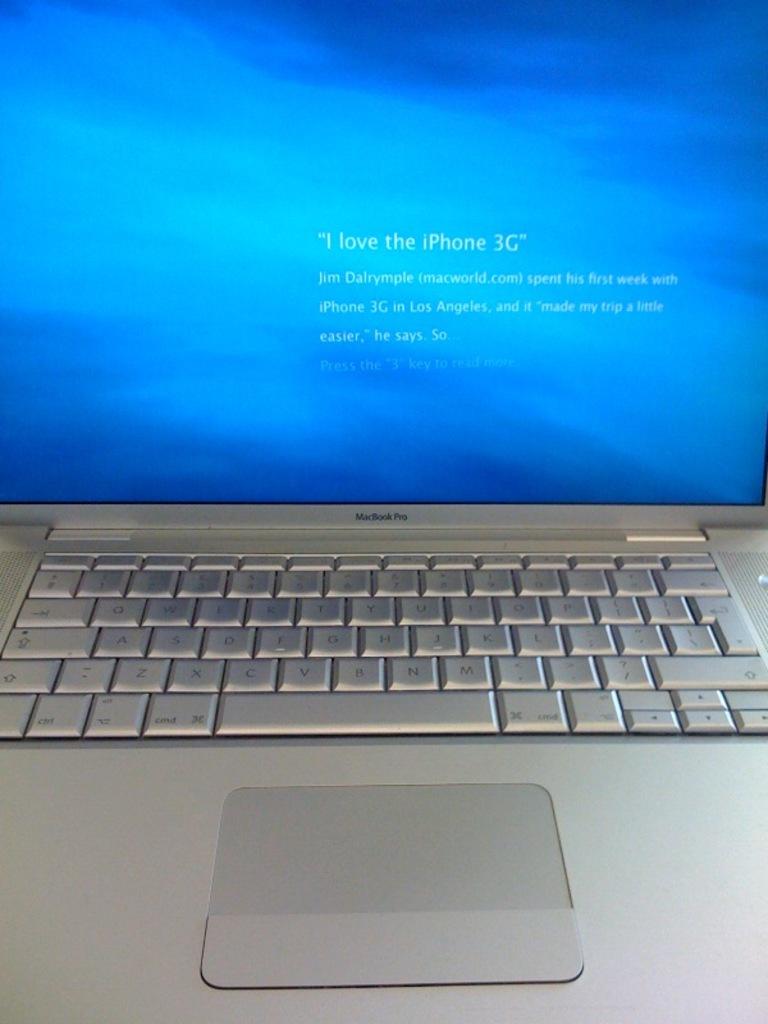What brand of laptop is this?
Offer a terse response. Macbook pro. What phone does he love/?
Your answer should be very brief. Iphone 3g. 